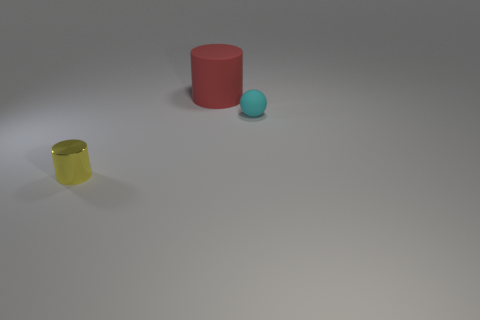What number of other objects are there of the same material as the tiny cylinder?
Provide a succinct answer. 0. What number of things are cylinders that are to the right of the yellow thing or objects that are in front of the big thing?
Your answer should be compact. 3. What is the material of the tiny yellow object that is the same shape as the red object?
Make the answer very short. Metal. Are there any gray shiny objects?
Provide a succinct answer. No. What size is the object that is both in front of the big red matte cylinder and right of the tiny yellow object?
Provide a succinct answer. Small. The metallic thing has what shape?
Give a very brief answer. Cylinder. There is a small object that is to the right of the tiny cylinder; is there a matte thing that is behind it?
Make the answer very short. Yes. There is a cylinder that is the same size as the cyan matte thing; what is its material?
Your response must be concise. Metal. Are there any blue metal balls that have the same size as the yellow cylinder?
Offer a very short reply. No. What is the cylinder that is behind the tiny cyan rubber thing made of?
Give a very brief answer. Rubber. 